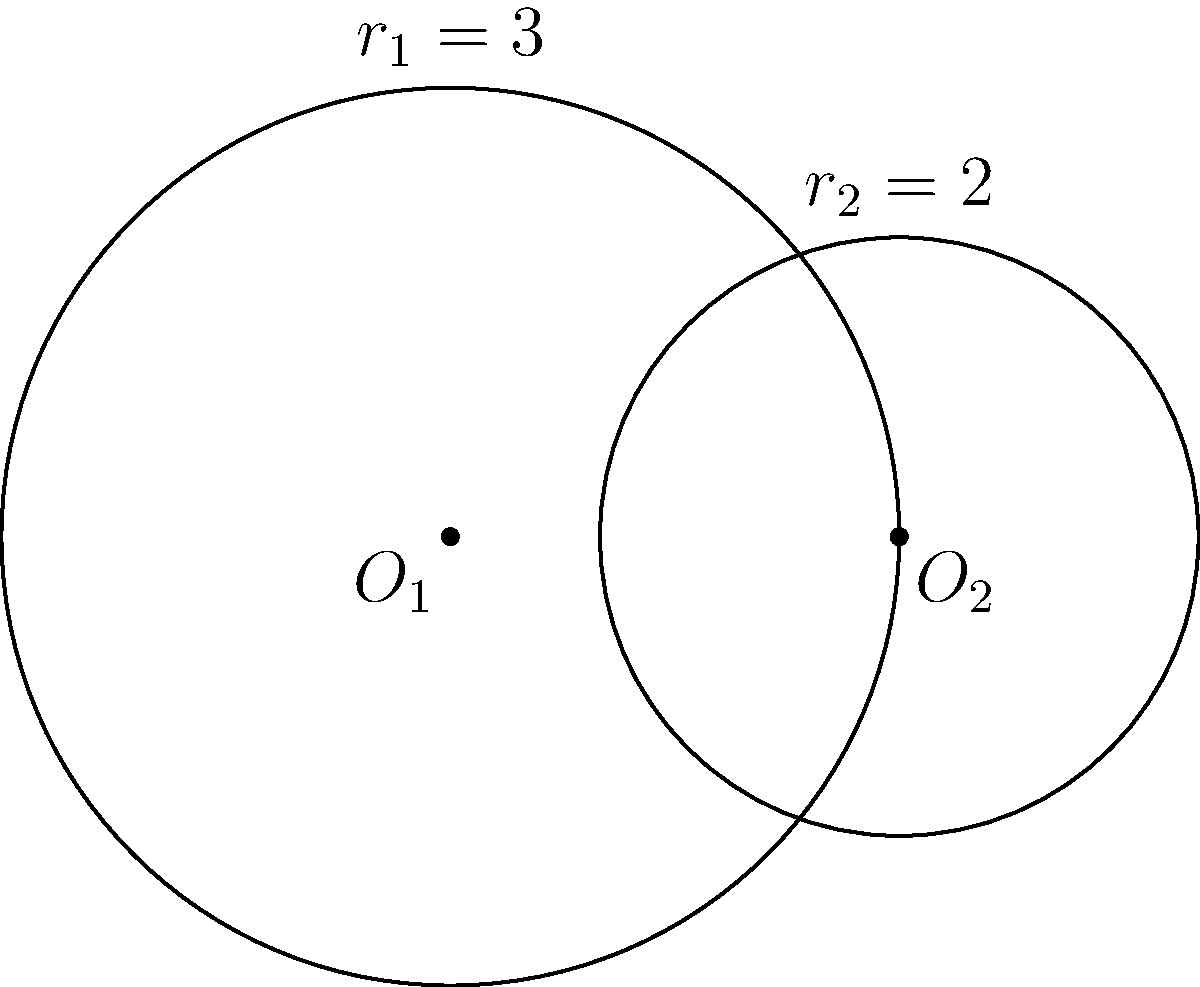In the context of visual storytelling in museums, consider two circular exhibits represented by the intersecting circles shown above. The equations of these circles are $(x^2 + y^2 = 9)$ and $((x-3)^2 + y^2 = 4)$. Calculate the area of the region where these exhibits overlap, which could represent the shared thematic space between two different stories. How might this overlap impact the visitor's understanding of the exhibits' interconnectedness? To find the area of the overlapping region, we'll follow these steps:

1) First, we need to find the distance between the centers of the circles. This is simply the difference in their x-coordinates: $d = 3$.

2) Now we can use the formula for the area of the lens created by two intersecting circles:

   $A = r_1^2 \arccos(\frac{d^2 + r_1^2 - r_2^2}{2dr_1}) + r_2^2 \arccos(\frac{d^2 + r_2^2 - r_1^2}{2dr_2}) - \frac{1}{2}\sqrt{(-d+r_1+r_2)(d+r_1-r_2)(d-r_1+r_2)(d+r_1+r_2)}$

3) Substituting our values:
   $r_1 = 3$, $r_2 = 2$, $d = 3$

4) Let's calculate each part:

   $\arccos(\frac{3^2 + 3^2 - 2^2}{2 \cdot 3 \cdot 3}) = \arccos(\frac{14}{18}) = \arccos(0.7778) \approx 0.6847$

   $\arccos(\frac{3^2 + 2^2 - 3^2}{2 \cdot 3 \cdot 2}) = \arccos(\frac{4}{12}) = \arccos(0.3333) \approx 1.2310$

   $\sqrt{(-3+3+2)(3+3-2)(3-3+2)(3+3+2)} = \sqrt{2 \cdot 4 \cdot 2 \cdot 8} = \sqrt{128} = 8\sqrt{2}$

5) Putting it all together:

   $A = 3^2 \cdot 0.6847 + 2^2 \cdot 1.2310 - \frac{1}{2} \cdot 8\sqrt{2}$
   
   $A = 6.1623 + 4.9240 - 5.6569$
   
   $A \approx 5.4294$ square units

This overlap represents the shared thematic space between the two exhibits. A larger overlap might suggest a stronger connection between the stories, potentially enhancing visitors' understanding of their interconnectedness. Conversely, a smaller overlap might indicate more distinct themes, which could either highlight contrasts or potentially lead to a more fragmented visitor experience.
Answer: $5.4294$ square units 